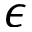Convert formula to latex. <formula><loc_0><loc_0><loc_500><loc_500>\epsilon</formula> 